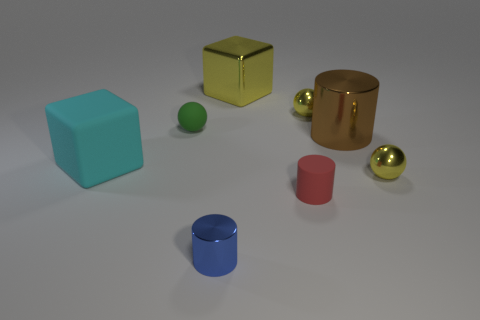Subtract all green cylinders. Subtract all yellow cubes. How many cylinders are left? 3 Add 1 small yellow shiny spheres. How many objects exist? 9 Subtract all cubes. How many objects are left? 6 Add 4 gray shiny objects. How many gray shiny objects exist? 4 Subtract 0 green cylinders. How many objects are left? 8 Subtract all cylinders. Subtract all green matte things. How many objects are left? 4 Add 7 cylinders. How many cylinders are left? 10 